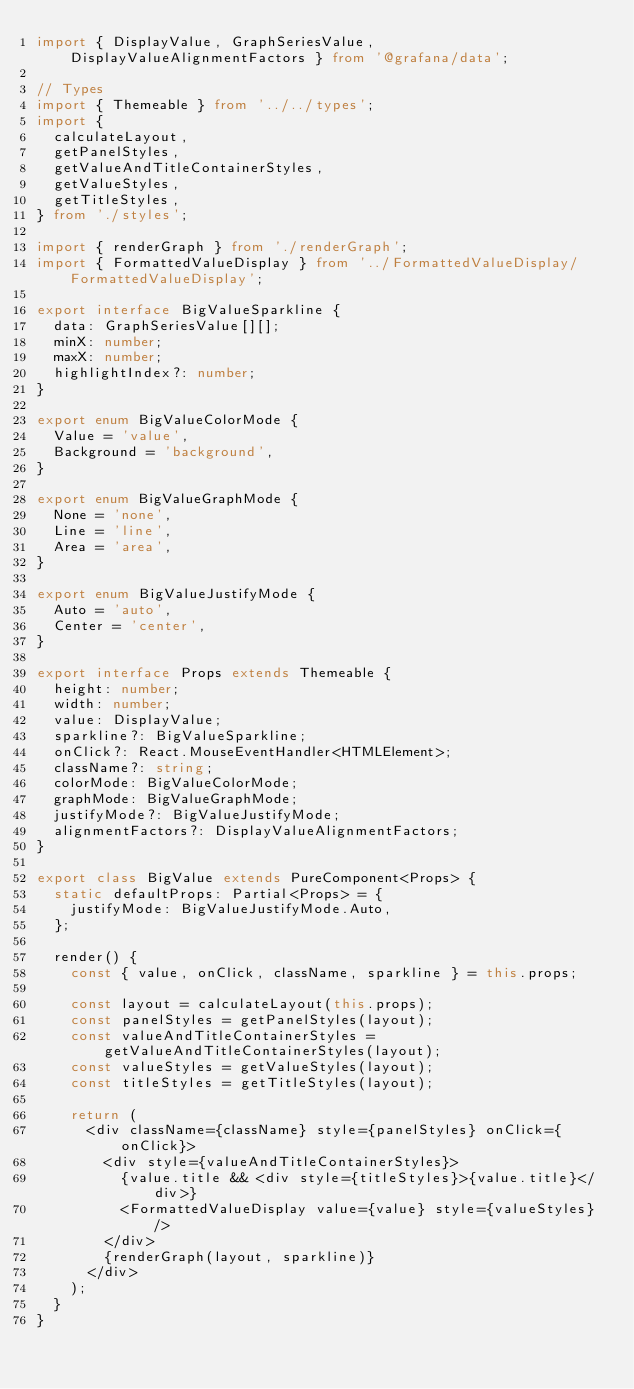Convert code to text. <code><loc_0><loc_0><loc_500><loc_500><_TypeScript_>import { DisplayValue, GraphSeriesValue, DisplayValueAlignmentFactors } from '@grafana/data';

// Types
import { Themeable } from '../../types';
import {
  calculateLayout,
  getPanelStyles,
  getValueAndTitleContainerStyles,
  getValueStyles,
  getTitleStyles,
} from './styles';

import { renderGraph } from './renderGraph';
import { FormattedValueDisplay } from '../FormattedValueDisplay/FormattedValueDisplay';

export interface BigValueSparkline {
  data: GraphSeriesValue[][];
  minX: number;
  maxX: number;
  highlightIndex?: number;
}

export enum BigValueColorMode {
  Value = 'value',
  Background = 'background',
}

export enum BigValueGraphMode {
  None = 'none',
  Line = 'line',
  Area = 'area',
}

export enum BigValueJustifyMode {
  Auto = 'auto',
  Center = 'center',
}

export interface Props extends Themeable {
  height: number;
  width: number;
  value: DisplayValue;
  sparkline?: BigValueSparkline;
  onClick?: React.MouseEventHandler<HTMLElement>;
  className?: string;
  colorMode: BigValueColorMode;
  graphMode: BigValueGraphMode;
  justifyMode?: BigValueJustifyMode;
  alignmentFactors?: DisplayValueAlignmentFactors;
}

export class BigValue extends PureComponent<Props> {
  static defaultProps: Partial<Props> = {
    justifyMode: BigValueJustifyMode.Auto,
  };

  render() {
    const { value, onClick, className, sparkline } = this.props;

    const layout = calculateLayout(this.props);
    const panelStyles = getPanelStyles(layout);
    const valueAndTitleContainerStyles = getValueAndTitleContainerStyles(layout);
    const valueStyles = getValueStyles(layout);
    const titleStyles = getTitleStyles(layout);

    return (
      <div className={className} style={panelStyles} onClick={onClick}>
        <div style={valueAndTitleContainerStyles}>
          {value.title && <div style={titleStyles}>{value.title}</div>}
          <FormattedValueDisplay value={value} style={valueStyles} />
        </div>
        {renderGraph(layout, sparkline)}
      </div>
    );
  }
}
</code> 